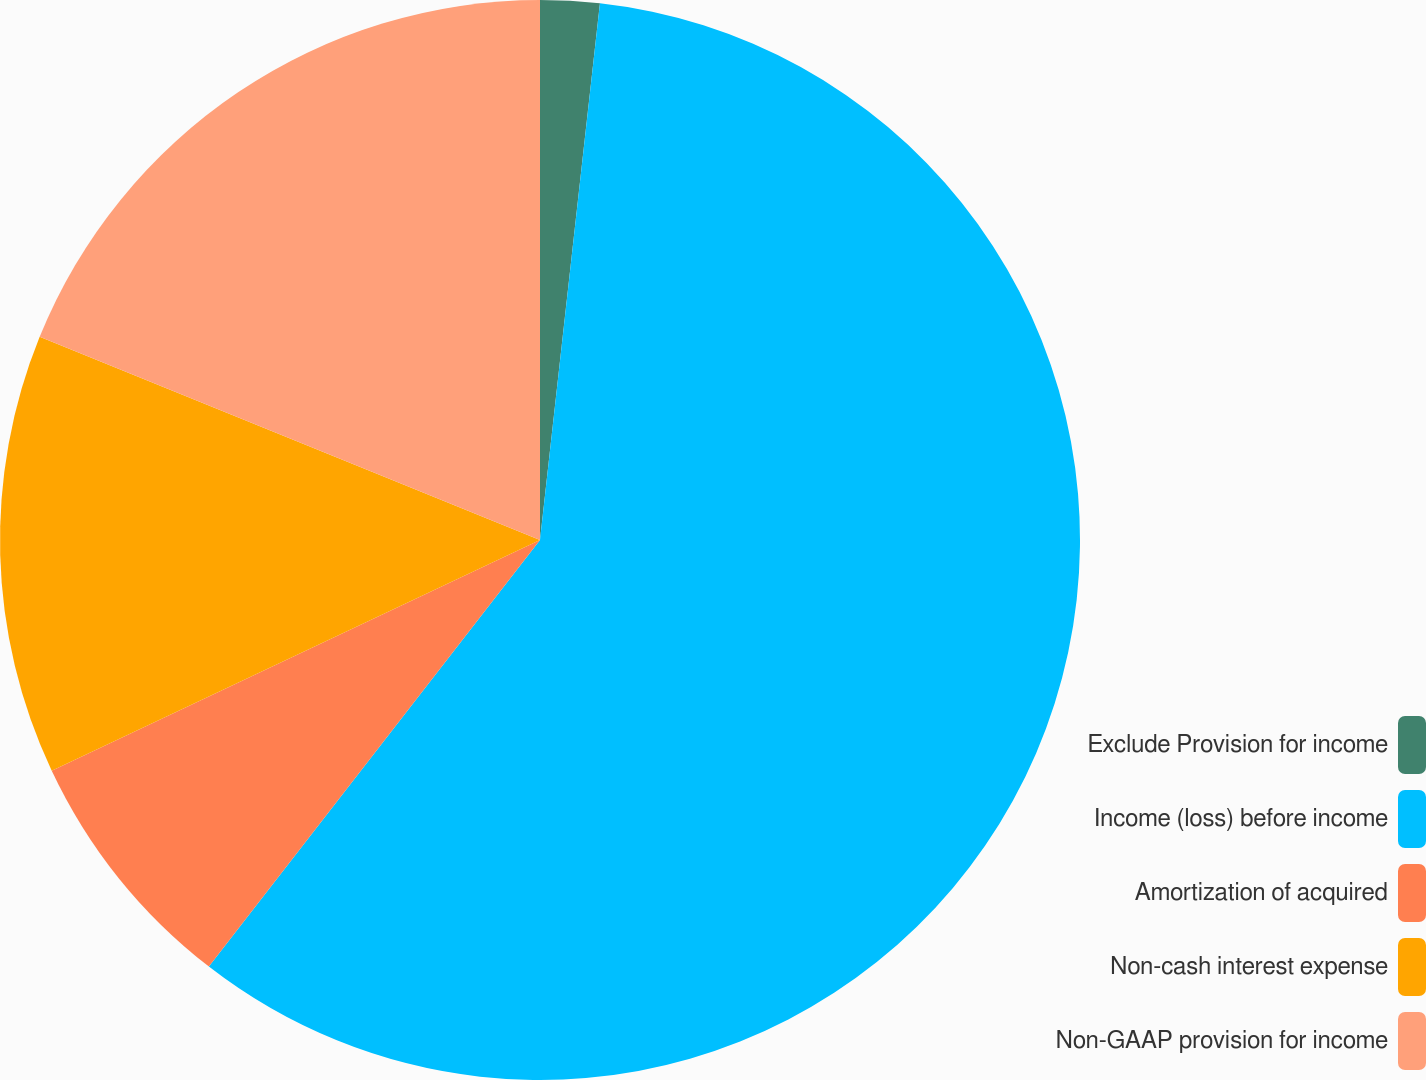Convert chart. <chart><loc_0><loc_0><loc_500><loc_500><pie_chart><fcel>Exclude Provision for income<fcel>Income (loss) before income<fcel>Amortization of acquired<fcel>Non-cash interest expense<fcel>Non-GAAP provision for income<nl><fcel>1.77%<fcel>58.73%<fcel>7.47%<fcel>13.16%<fcel>18.86%<nl></chart> 